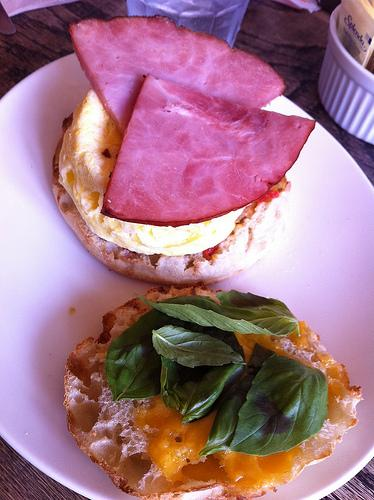Briefly describe the combination of ingredients placed on the english muffin. A toasted english muffin has a cooked egg, a slice of ham, melted cheddar cheese, and several green spinach leaves on it. Describe the appearance of the english muffin in the image and what is on top of it. The english muffin is toasted and has a slice of ham, egg, cheddar cheese, and green leaves on top of it. Mention the type of table and what is placed on it. A laminate wood topped table has a white oval ceramic plate with english muffins, a white container, and a drinking glass. Enumerate the various components found within the sandwich. The sandwich contains a toasted english muffin, ham, egg, cheddar cheese, and green leaves. Point out the primary food item on the sandwich. There is a triangular slice of pink ham on top of a yellow egg round on the sandwich. Identify the drink present in the image and the receptacle used. There is a glass of ice water in a clear drinking glass on the table. Briefly describe the components and arrangement of the sandwich. The sandwich consists of a toasted english muffin, egg, ham, cheddar cheese, and green leaves, stacked on top of each other. Mention the type of cheese on the sandwich and how it is served. Melted cheddar cheese is served on the sandwich, draping over the other ingredients. Describe the elements placed on the white ceramic plate. The white ceramic plate holds a sandwich made of a toasted english muffin, ham, egg, cheddar cheese, green leaves, and some crumbs. Mention the color of the table and what kind of surface it has. The table has a wooden surface and appears to have a laminate wood finish. 